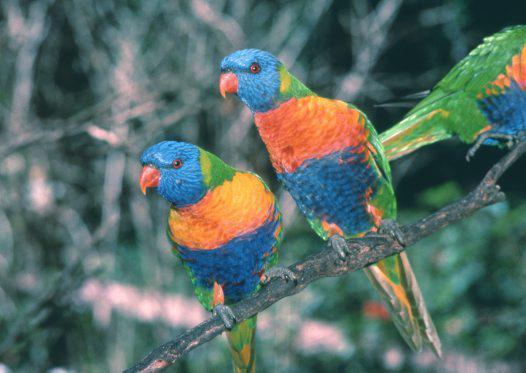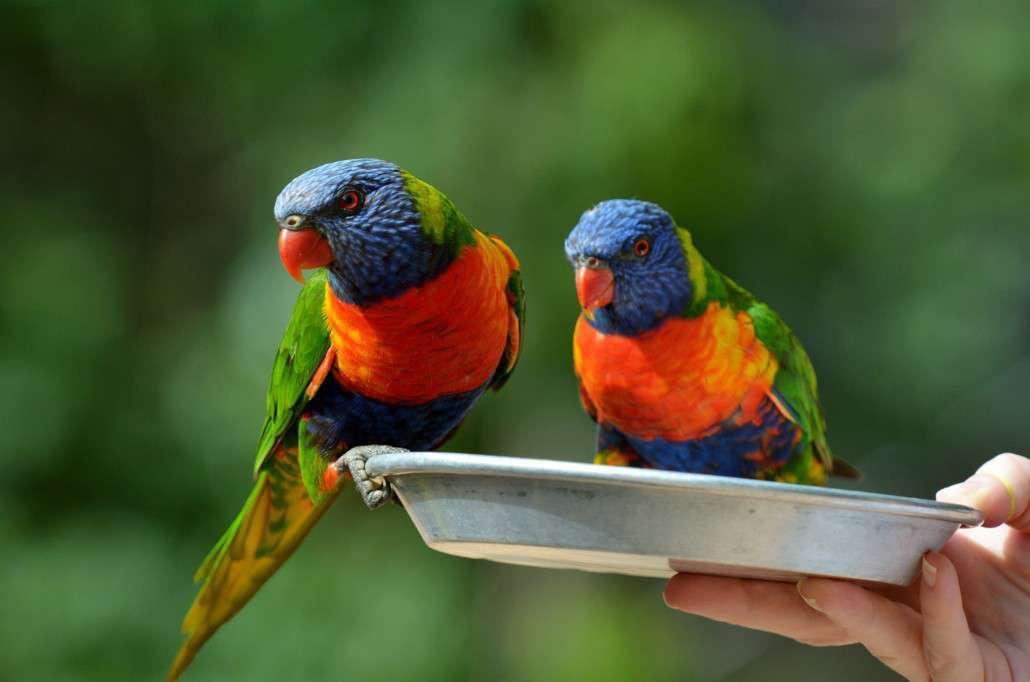The first image is the image on the left, the second image is the image on the right. Evaluate the accuracy of this statement regarding the images: "the right image has two birds next to each other on a branch". Is it true? Answer yes or no. No. 